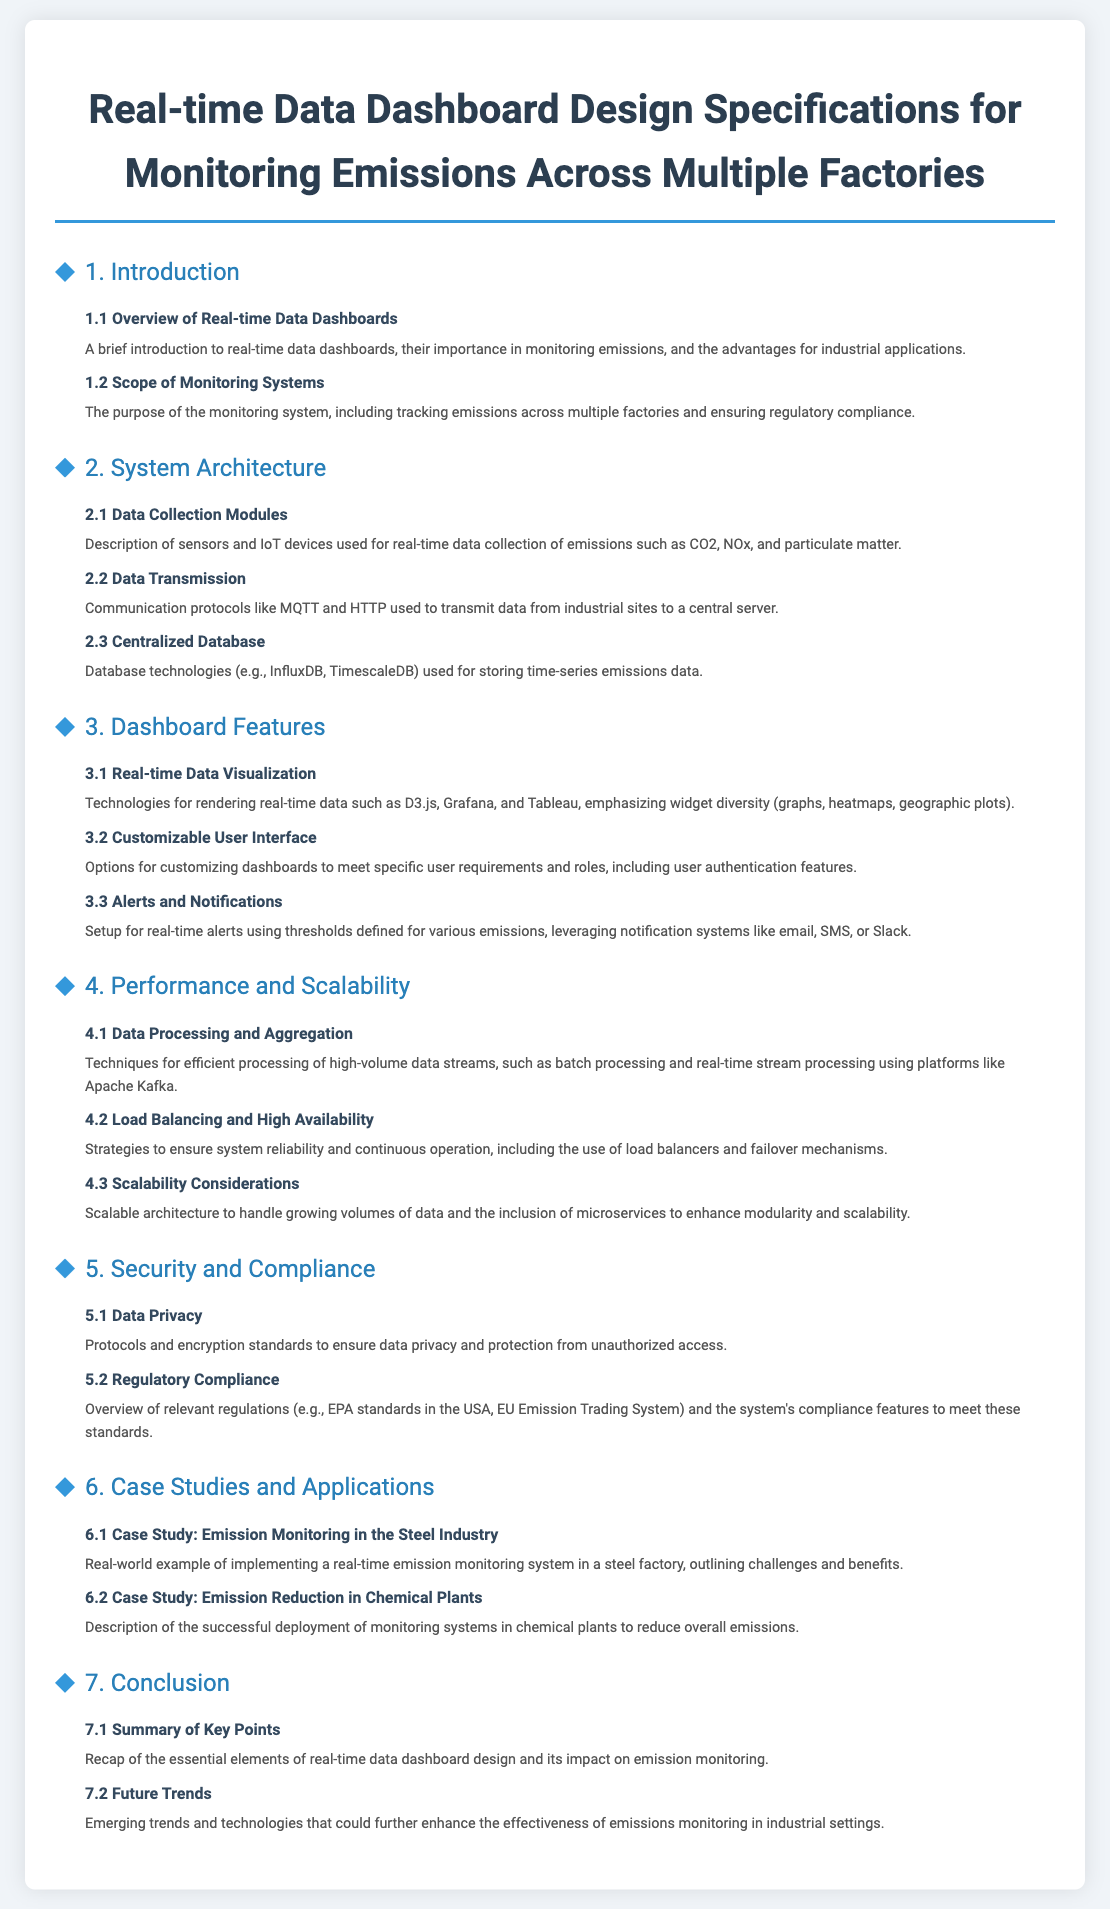What is the title of the document? The title is found in the header of the document, presenting the main subject covered.
Answer: Real-time Data Dashboard Design Specifications for Monitoring Emissions Across Multiple Factories Which section discusses data collection modules? Section 2 of the document is dedicated to System Architecture, with subsection 2.1 specifically focusing on Data Collection Modules.
Answer: 2.1 Data Collection Modules What technologies are mentioned for data storage? Section 2.3 describes technologies for storing emissions data, providing specific examples used for this purpose.
Answer: InfluxDB, TimescaleDB How many case studies are presented? Section 6 contains two subsections providing details on different case studies relating to emission monitoring systems.
Answer: 2 What is a benefit of real-time data dashboards mentioned? The document overview describes advantages of real-time data dashboards, specifically their importance in monitoring emissions.
Answer: Monitoring emissions What does the document mention as a communication protocol? In subsection 2.2, specific protocols used for data transmission from factories to servers are detailed.
Answer: MQTT, HTTP Which section covers security and compliance? The section that addresses aspects related to data safety and meeting legal standards is listed as Section 5.
Answer: 5. Security and Compliance What emerging aspect is discussed under future trends? Subsection 7.2 touches upon new developments in technology that may impact emissions monitoring in the future.
Answer: Emerging trends and technologies 